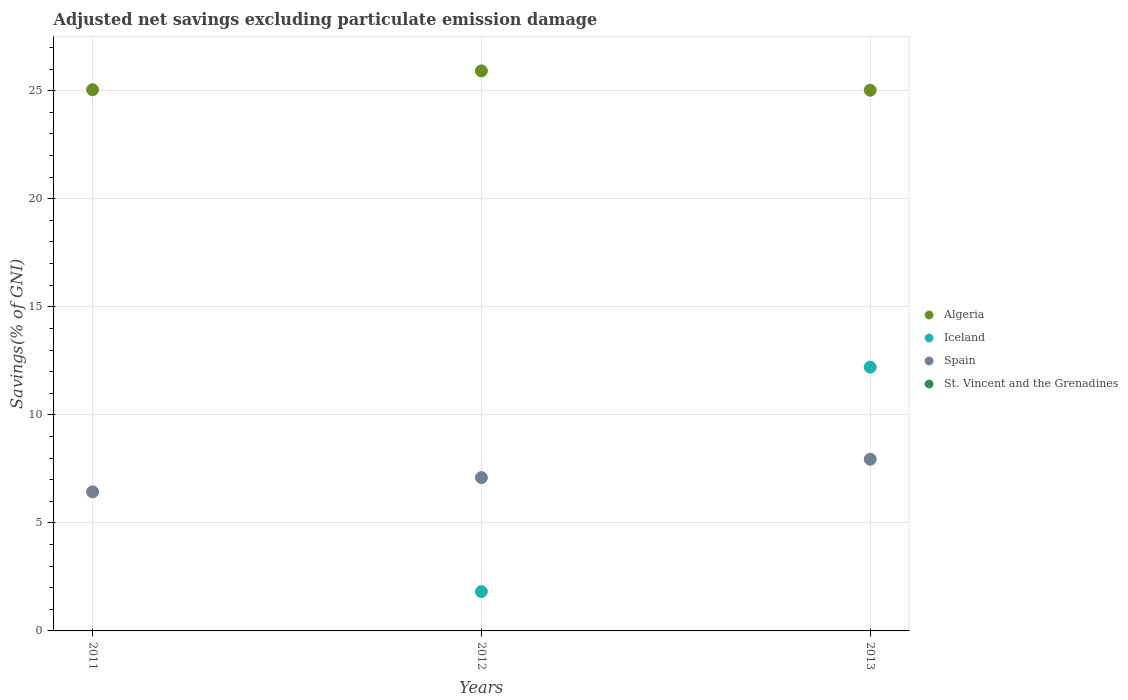How many different coloured dotlines are there?
Ensure brevity in your answer.  3. Across all years, what is the maximum adjusted net savings in Algeria?
Your answer should be compact. 25.92. What is the total adjusted net savings in Spain in the graph?
Give a very brief answer. 21.48. What is the difference between the adjusted net savings in Spain in 2012 and that in 2013?
Give a very brief answer. -0.85. What is the difference between the adjusted net savings in Iceland in 2013 and the adjusted net savings in Spain in 2012?
Keep it short and to the point. 5.11. What is the average adjusted net savings in St. Vincent and the Grenadines per year?
Make the answer very short. 0. In the year 2012, what is the difference between the adjusted net savings in Algeria and adjusted net savings in Spain?
Provide a short and direct response. 18.82. What is the ratio of the adjusted net savings in Algeria in 2011 to that in 2013?
Offer a very short reply. 1. Is the adjusted net savings in Spain in 2011 less than that in 2012?
Your answer should be very brief. Yes. Is the difference between the adjusted net savings in Algeria in 2011 and 2013 greater than the difference between the adjusted net savings in Spain in 2011 and 2013?
Provide a succinct answer. Yes. What is the difference between the highest and the second highest adjusted net savings in Algeria?
Offer a terse response. 0.87. What is the difference between the highest and the lowest adjusted net savings in Iceland?
Provide a succinct answer. 12.2. In how many years, is the adjusted net savings in Algeria greater than the average adjusted net savings in Algeria taken over all years?
Provide a succinct answer. 1. Is the sum of the adjusted net savings in Spain in 2011 and 2013 greater than the maximum adjusted net savings in Iceland across all years?
Keep it short and to the point. Yes. Does the adjusted net savings in St. Vincent and the Grenadines monotonically increase over the years?
Ensure brevity in your answer.  No. Is the adjusted net savings in Spain strictly greater than the adjusted net savings in Algeria over the years?
Give a very brief answer. No. Is the adjusted net savings in Iceland strictly less than the adjusted net savings in St. Vincent and the Grenadines over the years?
Your answer should be compact. No. How many years are there in the graph?
Provide a succinct answer. 3. Does the graph contain grids?
Give a very brief answer. Yes. How many legend labels are there?
Your answer should be compact. 4. What is the title of the graph?
Your answer should be very brief. Adjusted net savings excluding particulate emission damage. Does "Somalia" appear as one of the legend labels in the graph?
Your answer should be very brief. No. What is the label or title of the Y-axis?
Ensure brevity in your answer.  Savings(% of GNI). What is the Savings(% of GNI) of Algeria in 2011?
Provide a succinct answer. 25.05. What is the Savings(% of GNI) of Iceland in 2011?
Your answer should be very brief. 0. What is the Savings(% of GNI) in Spain in 2011?
Provide a short and direct response. 6.44. What is the Savings(% of GNI) of St. Vincent and the Grenadines in 2011?
Offer a terse response. 0. What is the Savings(% of GNI) in Algeria in 2012?
Ensure brevity in your answer.  25.92. What is the Savings(% of GNI) in Iceland in 2012?
Offer a terse response. 1.82. What is the Savings(% of GNI) in Spain in 2012?
Give a very brief answer. 7.1. What is the Savings(% of GNI) of Algeria in 2013?
Keep it short and to the point. 25.02. What is the Savings(% of GNI) in Iceland in 2013?
Ensure brevity in your answer.  12.2. What is the Savings(% of GNI) of Spain in 2013?
Ensure brevity in your answer.  7.95. Across all years, what is the maximum Savings(% of GNI) in Algeria?
Your answer should be compact. 25.92. Across all years, what is the maximum Savings(% of GNI) in Iceland?
Provide a short and direct response. 12.2. Across all years, what is the maximum Savings(% of GNI) of Spain?
Your answer should be compact. 7.95. Across all years, what is the minimum Savings(% of GNI) in Algeria?
Provide a succinct answer. 25.02. Across all years, what is the minimum Savings(% of GNI) in Iceland?
Ensure brevity in your answer.  0. Across all years, what is the minimum Savings(% of GNI) in Spain?
Offer a very short reply. 6.44. What is the total Savings(% of GNI) in Algeria in the graph?
Your answer should be very brief. 75.98. What is the total Savings(% of GNI) of Iceland in the graph?
Give a very brief answer. 14.02. What is the total Savings(% of GNI) of Spain in the graph?
Make the answer very short. 21.48. What is the total Savings(% of GNI) in St. Vincent and the Grenadines in the graph?
Make the answer very short. 0. What is the difference between the Savings(% of GNI) of Algeria in 2011 and that in 2012?
Provide a short and direct response. -0.87. What is the difference between the Savings(% of GNI) in Spain in 2011 and that in 2012?
Your answer should be compact. -0.66. What is the difference between the Savings(% of GNI) of Algeria in 2011 and that in 2013?
Keep it short and to the point. 0.02. What is the difference between the Savings(% of GNI) of Spain in 2011 and that in 2013?
Provide a short and direct response. -1.51. What is the difference between the Savings(% of GNI) in Algeria in 2012 and that in 2013?
Keep it short and to the point. 0.89. What is the difference between the Savings(% of GNI) in Iceland in 2012 and that in 2013?
Offer a very short reply. -10.39. What is the difference between the Savings(% of GNI) of Spain in 2012 and that in 2013?
Provide a succinct answer. -0.85. What is the difference between the Savings(% of GNI) of Algeria in 2011 and the Savings(% of GNI) of Iceland in 2012?
Make the answer very short. 23.23. What is the difference between the Savings(% of GNI) in Algeria in 2011 and the Savings(% of GNI) in Spain in 2012?
Your answer should be compact. 17.95. What is the difference between the Savings(% of GNI) in Algeria in 2011 and the Savings(% of GNI) in Iceland in 2013?
Your answer should be compact. 12.84. What is the difference between the Savings(% of GNI) of Algeria in 2011 and the Savings(% of GNI) of Spain in 2013?
Ensure brevity in your answer.  17.1. What is the difference between the Savings(% of GNI) of Algeria in 2012 and the Savings(% of GNI) of Iceland in 2013?
Give a very brief answer. 13.71. What is the difference between the Savings(% of GNI) of Algeria in 2012 and the Savings(% of GNI) of Spain in 2013?
Your answer should be very brief. 17.97. What is the difference between the Savings(% of GNI) of Iceland in 2012 and the Savings(% of GNI) of Spain in 2013?
Offer a very short reply. -6.13. What is the average Savings(% of GNI) in Algeria per year?
Ensure brevity in your answer.  25.33. What is the average Savings(% of GNI) of Iceland per year?
Give a very brief answer. 4.67. What is the average Savings(% of GNI) of Spain per year?
Give a very brief answer. 7.16. What is the average Savings(% of GNI) of St. Vincent and the Grenadines per year?
Your answer should be very brief. 0. In the year 2011, what is the difference between the Savings(% of GNI) in Algeria and Savings(% of GNI) in Spain?
Your response must be concise. 18.61. In the year 2012, what is the difference between the Savings(% of GNI) of Algeria and Savings(% of GNI) of Iceland?
Offer a terse response. 24.1. In the year 2012, what is the difference between the Savings(% of GNI) in Algeria and Savings(% of GNI) in Spain?
Make the answer very short. 18.82. In the year 2012, what is the difference between the Savings(% of GNI) in Iceland and Savings(% of GNI) in Spain?
Make the answer very short. -5.28. In the year 2013, what is the difference between the Savings(% of GNI) in Algeria and Savings(% of GNI) in Iceland?
Your answer should be very brief. 12.82. In the year 2013, what is the difference between the Savings(% of GNI) of Algeria and Savings(% of GNI) of Spain?
Your response must be concise. 17.08. In the year 2013, what is the difference between the Savings(% of GNI) in Iceland and Savings(% of GNI) in Spain?
Your answer should be compact. 4.26. What is the ratio of the Savings(% of GNI) in Algeria in 2011 to that in 2012?
Give a very brief answer. 0.97. What is the ratio of the Savings(% of GNI) of Spain in 2011 to that in 2012?
Provide a short and direct response. 0.91. What is the ratio of the Savings(% of GNI) in Algeria in 2011 to that in 2013?
Ensure brevity in your answer.  1. What is the ratio of the Savings(% of GNI) in Spain in 2011 to that in 2013?
Give a very brief answer. 0.81. What is the ratio of the Savings(% of GNI) of Algeria in 2012 to that in 2013?
Your answer should be very brief. 1.04. What is the ratio of the Savings(% of GNI) of Iceland in 2012 to that in 2013?
Provide a succinct answer. 0.15. What is the ratio of the Savings(% of GNI) in Spain in 2012 to that in 2013?
Keep it short and to the point. 0.89. What is the difference between the highest and the second highest Savings(% of GNI) in Algeria?
Provide a succinct answer. 0.87. What is the difference between the highest and the second highest Savings(% of GNI) in Spain?
Give a very brief answer. 0.85. What is the difference between the highest and the lowest Savings(% of GNI) of Algeria?
Provide a succinct answer. 0.89. What is the difference between the highest and the lowest Savings(% of GNI) in Iceland?
Make the answer very short. 12.2. What is the difference between the highest and the lowest Savings(% of GNI) of Spain?
Give a very brief answer. 1.51. 